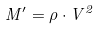<formula> <loc_0><loc_0><loc_500><loc_500>M ^ { \prime } = \rho \cdot V ^ { 2 }</formula> 